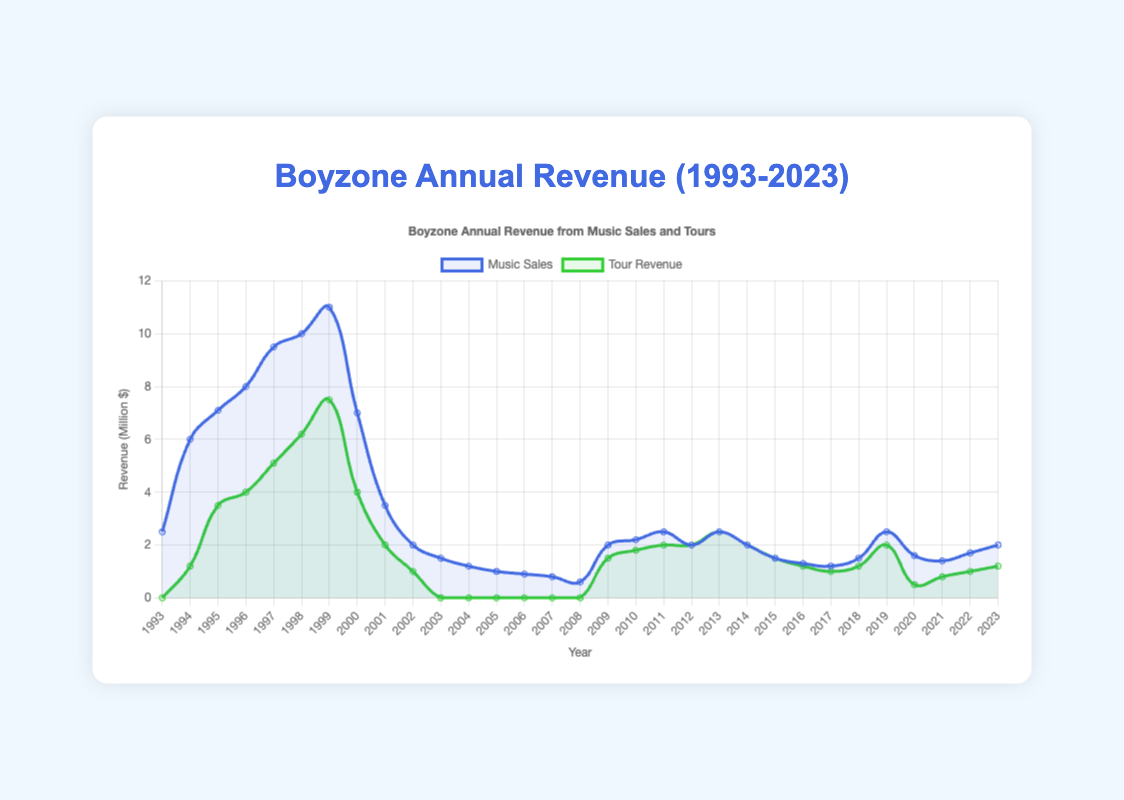What year had the highest music sales? The highest music sales are represented by the peak point in the blue line. From the chart, this peak occurs in the year 1999 with $11.0 million.
Answer: 1999 Do music sales exceed tour revenue in 1999? In 1999, look at the height difference between the blue and green lines; the blue line (music sales) is at $11.0 million while the green line (tour revenue) is at $7.5 million. Therefore, music sales exceed tour revenue.
Answer: Yes Which year had the greatest combined revenue from music sales and tours? To find the greatest combined revenue, sum both revenues for each year. The highest combined revenue is found in 1999: $11.0 million (music sales) + $7.5 million (tour revenue) = $18.5 million.
Answer: 1999 How did tour revenue change from 1994 to 1995? Check the green line's height at 1994 and 1995. Tour revenue increased from $1.2 million in 1994 to $3.5 million in 1995. The change is $3.5 million - $1.2 million = $2.3 million.
Answer: Increased by $2.3 million What is the average music sales revenue from 2005 to 2007? Add music sales revenues from 2005 ($1.0 million), 2006 ($0.9 million), and 2007 ($0.8 million), then divide by 3. The calculation: ($1.0 + $0.9 + $0.8) / 3 = $0.9 million is the average.
Answer: $0.9 million Did Boyzone earn more from music sales or tour revenue in 2020? Compare the height of the blue and green lines in 2020. Music sales are at $1.6 million, whereas tour revenue is at $0.5 million. Music sales revenue is higher.
Answer: Music sales In which year did Boyzone have no tour revenue but still had music sales? Identify the years where the green line is at 0 but the blue line is not. This occurs in 1993, 2003, 2004, 2005, 2006, 2007, and 2008.
Answer: 1993, 2003, 2004, 2005, 2006, 2007, 2008 What was the difference between music sales and tour revenue in 2013? In 2013, music sales are $2.5 million and tour revenue is $2.5 million. The difference is $2.5 million - $2.5 million = $0 million.
Answer: $0 million How does the trend in music sales compare to tour revenue from 2009 to 2013? From 2009 to 2013, both the blue and green lines generally trend upward with small fluctuations. In 2009, music sales are at $2.0 million and tour revenue at $1.5 million, rising to $2.5 million each by 2013. The parallel trend can be observed in both revenues.
Answer: Parallel upward trend How many years did Boyzone’s tour revenue exceed $5 million? Locate the green line and count the years it is above the $5 million mark. This occurs in 1998 ($6.2 million) and 1999 ($7.5 million).
Answer: 2 years 